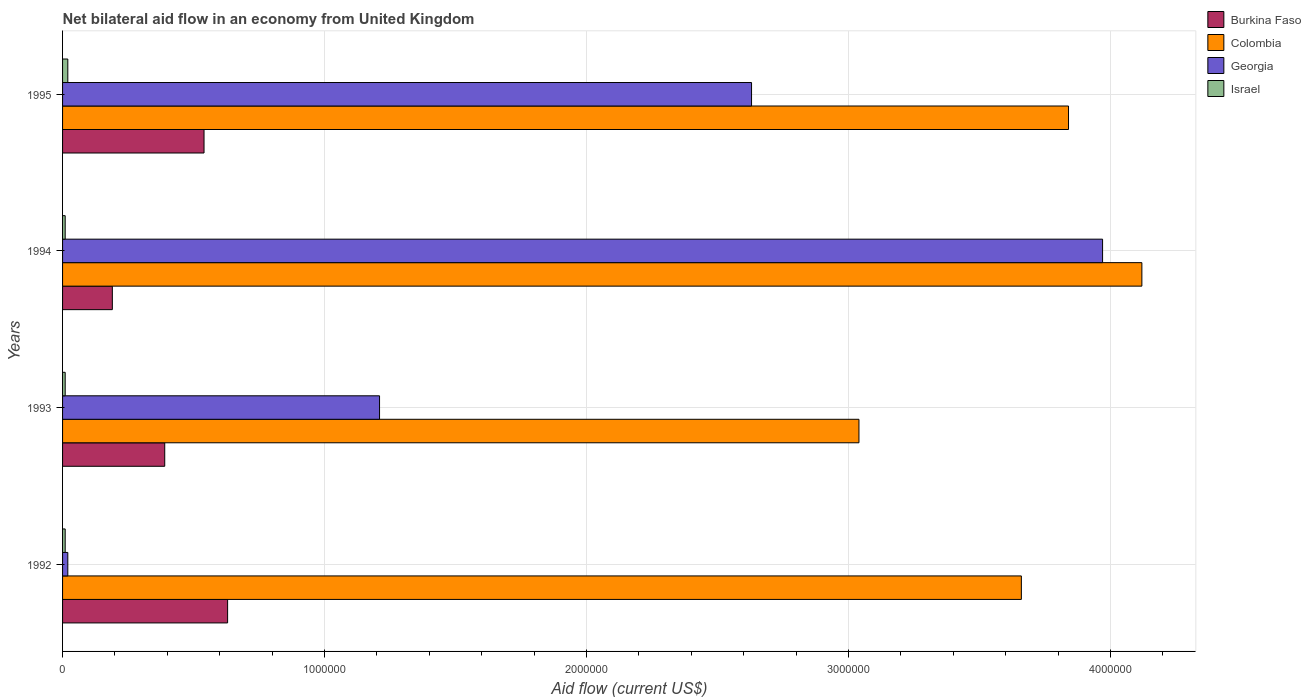How many different coloured bars are there?
Keep it short and to the point. 4. How many bars are there on the 4th tick from the bottom?
Your answer should be very brief. 4. What is the net bilateral aid flow in Colombia in 1993?
Your answer should be compact. 3.04e+06. Across all years, what is the maximum net bilateral aid flow in Georgia?
Give a very brief answer. 3.97e+06. What is the total net bilateral aid flow in Georgia in the graph?
Offer a very short reply. 7.83e+06. What is the difference between the net bilateral aid flow in Colombia in 1993 and that in 1995?
Offer a terse response. -8.00e+05. What is the difference between the net bilateral aid flow in Israel in 1993 and the net bilateral aid flow in Colombia in 1995?
Your answer should be very brief. -3.83e+06. What is the average net bilateral aid flow in Colombia per year?
Offer a terse response. 3.66e+06. In the year 1994, what is the difference between the net bilateral aid flow in Georgia and net bilateral aid flow in Israel?
Your response must be concise. 3.96e+06. What is the ratio of the net bilateral aid flow in Georgia in 1992 to that in 1994?
Provide a short and direct response. 0.01. What is the difference between the highest and the second highest net bilateral aid flow in Colombia?
Give a very brief answer. 2.80e+05. What is the difference between the highest and the lowest net bilateral aid flow in Burkina Faso?
Your answer should be compact. 4.40e+05. Is the sum of the net bilateral aid flow in Israel in 1993 and 1994 greater than the maximum net bilateral aid flow in Georgia across all years?
Your answer should be compact. No. Is it the case that in every year, the sum of the net bilateral aid flow in Georgia and net bilateral aid flow in Burkina Faso is greater than the sum of net bilateral aid flow in Colombia and net bilateral aid flow in Israel?
Your answer should be compact. Yes. What does the 1st bar from the bottom in 1994 represents?
Give a very brief answer. Burkina Faso. Is it the case that in every year, the sum of the net bilateral aid flow in Colombia and net bilateral aid flow in Georgia is greater than the net bilateral aid flow in Israel?
Provide a succinct answer. Yes. How many bars are there?
Your response must be concise. 16. Are all the bars in the graph horizontal?
Ensure brevity in your answer.  Yes. What is the difference between two consecutive major ticks on the X-axis?
Provide a short and direct response. 1.00e+06. Are the values on the major ticks of X-axis written in scientific E-notation?
Your answer should be very brief. No. Does the graph contain any zero values?
Ensure brevity in your answer.  No. Does the graph contain grids?
Keep it short and to the point. Yes. What is the title of the graph?
Keep it short and to the point. Net bilateral aid flow in an economy from United Kingdom. What is the label or title of the X-axis?
Give a very brief answer. Aid flow (current US$). What is the Aid flow (current US$) of Burkina Faso in 1992?
Provide a short and direct response. 6.30e+05. What is the Aid flow (current US$) of Colombia in 1992?
Your response must be concise. 3.66e+06. What is the Aid flow (current US$) of Israel in 1992?
Give a very brief answer. 10000. What is the Aid flow (current US$) of Colombia in 1993?
Offer a terse response. 3.04e+06. What is the Aid flow (current US$) in Georgia in 1993?
Provide a succinct answer. 1.21e+06. What is the Aid flow (current US$) in Burkina Faso in 1994?
Provide a short and direct response. 1.90e+05. What is the Aid flow (current US$) in Colombia in 1994?
Provide a succinct answer. 4.12e+06. What is the Aid flow (current US$) of Georgia in 1994?
Provide a short and direct response. 3.97e+06. What is the Aid flow (current US$) in Israel in 1994?
Provide a short and direct response. 10000. What is the Aid flow (current US$) in Burkina Faso in 1995?
Make the answer very short. 5.40e+05. What is the Aid flow (current US$) of Colombia in 1995?
Provide a short and direct response. 3.84e+06. What is the Aid flow (current US$) in Georgia in 1995?
Make the answer very short. 2.63e+06. Across all years, what is the maximum Aid flow (current US$) of Burkina Faso?
Offer a very short reply. 6.30e+05. Across all years, what is the maximum Aid flow (current US$) of Colombia?
Offer a very short reply. 4.12e+06. Across all years, what is the maximum Aid flow (current US$) of Georgia?
Your answer should be very brief. 3.97e+06. Across all years, what is the maximum Aid flow (current US$) of Israel?
Your answer should be very brief. 2.00e+04. Across all years, what is the minimum Aid flow (current US$) of Colombia?
Provide a succinct answer. 3.04e+06. Across all years, what is the minimum Aid flow (current US$) in Georgia?
Offer a terse response. 2.00e+04. Across all years, what is the minimum Aid flow (current US$) of Israel?
Provide a short and direct response. 10000. What is the total Aid flow (current US$) in Burkina Faso in the graph?
Offer a terse response. 1.75e+06. What is the total Aid flow (current US$) of Colombia in the graph?
Offer a very short reply. 1.47e+07. What is the total Aid flow (current US$) of Georgia in the graph?
Make the answer very short. 7.83e+06. What is the difference between the Aid flow (current US$) in Colombia in 1992 and that in 1993?
Your answer should be compact. 6.20e+05. What is the difference between the Aid flow (current US$) in Georgia in 1992 and that in 1993?
Offer a terse response. -1.19e+06. What is the difference between the Aid flow (current US$) in Burkina Faso in 1992 and that in 1994?
Offer a terse response. 4.40e+05. What is the difference between the Aid flow (current US$) in Colombia in 1992 and that in 1994?
Offer a terse response. -4.60e+05. What is the difference between the Aid flow (current US$) in Georgia in 1992 and that in 1994?
Make the answer very short. -3.95e+06. What is the difference between the Aid flow (current US$) in Burkina Faso in 1992 and that in 1995?
Offer a terse response. 9.00e+04. What is the difference between the Aid flow (current US$) of Georgia in 1992 and that in 1995?
Ensure brevity in your answer.  -2.61e+06. What is the difference between the Aid flow (current US$) in Israel in 1992 and that in 1995?
Give a very brief answer. -10000. What is the difference between the Aid flow (current US$) of Burkina Faso in 1993 and that in 1994?
Provide a succinct answer. 2.00e+05. What is the difference between the Aid flow (current US$) of Colombia in 1993 and that in 1994?
Offer a terse response. -1.08e+06. What is the difference between the Aid flow (current US$) of Georgia in 1993 and that in 1994?
Ensure brevity in your answer.  -2.76e+06. What is the difference between the Aid flow (current US$) in Israel in 1993 and that in 1994?
Offer a very short reply. 0. What is the difference between the Aid flow (current US$) of Colombia in 1993 and that in 1995?
Your answer should be compact. -8.00e+05. What is the difference between the Aid flow (current US$) of Georgia in 1993 and that in 1995?
Provide a succinct answer. -1.42e+06. What is the difference between the Aid flow (current US$) of Burkina Faso in 1994 and that in 1995?
Give a very brief answer. -3.50e+05. What is the difference between the Aid flow (current US$) of Georgia in 1994 and that in 1995?
Keep it short and to the point. 1.34e+06. What is the difference between the Aid flow (current US$) in Israel in 1994 and that in 1995?
Your answer should be very brief. -10000. What is the difference between the Aid flow (current US$) in Burkina Faso in 1992 and the Aid flow (current US$) in Colombia in 1993?
Your response must be concise. -2.41e+06. What is the difference between the Aid flow (current US$) in Burkina Faso in 1992 and the Aid flow (current US$) in Georgia in 1993?
Your response must be concise. -5.80e+05. What is the difference between the Aid flow (current US$) of Burkina Faso in 1992 and the Aid flow (current US$) of Israel in 1993?
Offer a terse response. 6.20e+05. What is the difference between the Aid flow (current US$) of Colombia in 1992 and the Aid flow (current US$) of Georgia in 1993?
Provide a succinct answer. 2.45e+06. What is the difference between the Aid flow (current US$) of Colombia in 1992 and the Aid flow (current US$) of Israel in 1993?
Offer a terse response. 3.65e+06. What is the difference between the Aid flow (current US$) in Burkina Faso in 1992 and the Aid flow (current US$) in Colombia in 1994?
Your answer should be compact. -3.49e+06. What is the difference between the Aid flow (current US$) in Burkina Faso in 1992 and the Aid flow (current US$) in Georgia in 1994?
Ensure brevity in your answer.  -3.34e+06. What is the difference between the Aid flow (current US$) in Burkina Faso in 1992 and the Aid flow (current US$) in Israel in 1994?
Ensure brevity in your answer.  6.20e+05. What is the difference between the Aid flow (current US$) in Colombia in 1992 and the Aid flow (current US$) in Georgia in 1994?
Make the answer very short. -3.10e+05. What is the difference between the Aid flow (current US$) of Colombia in 1992 and the Aid flow (current US$) of Israel in 1994?
Provide a succinct answer. 3.65e+06. What is the difference between the Aid flow (current US$) of Georgia in 1992 and the Aid flow (current US$) of Israel in 1994?
Your answer should be compact. 10000. What is the difference between the Aid flow (current US$) in Burkina Faso in 1992 and the Aid flow (current US$) in Colombia in 1995?
Your answer should be compact. -3.21e+06. What is the difference between the Aid flow (current US$) of Burkina Faso in 1992 and the Aid flow (current US$) of Georgia in 1995?
Ensure brevity in your answer.  -2.00e+06. What is the difference between the Aid flow (current US$) of Burkina Faso in 1992 and the Aid flow (current US$) of Israel in 1995?
Give a very brief answer. 6.10e+05. What is the difference between the Aid flow (current US$) in Colombia in 1992 and the Aid flow (current US$) in Georgia in 1995?
Your answer should be very brief. 1.03e+06. What is the difference between the Aid flow (current US$) of Colombia in 1992 and the Aid flow (current US$) of Israel in 1995?
Offer a very short reply. 3.64e+06. What is the difference between the Aid flow (current US$) in Georgia in 1992 and the Aid flow (current US$) in Israel in 1995?
Give a very brief answer. 0. What is the difference between the Aid flow (current US$) of Burkina Faso in 1993 and the Aid flow (current US$) of Colombia in 1994?
Provide a succinct answer. -3.73e+06. What is the difference between the Aid flow (current US$) of Burkina Faso in 1993 and the Aid flow (current US$) of Georgia in 1994?
Offer a terse response. -3.58e+06. What is the difference between the Aid flow (current US$) of Burkina Faso in 1993 and the Aid flow (current US$) of Israel in 1994?
Your answer should be very brief. 3.80e+05. What is the difference between the Aid flow (current US$) in Colombia in 1993 and the Aid flow (current US$) in Georgia in 1994?
Ensure brevity in your answer.  -9.30e+05. What is the difference between the Aid flow (current US$) of Colombia in 1993 and the Aid flow (current US$) of Israel in 1994?
Offer a terse response. 3.03e+06. What is the difference between the Aid flow (current US$) of Georgia in 1993 and the Aid flow (current US$) of Israel in 1994?
Your answer should be compact. 1.20e+06. What is the difference between the Aid flow (current US$) of Burkina Faso in 1993 and the Aid flow (current US$) of Colombia in 1995?
Give a very brief answer. -3.45e+06. What is the difference between the Aid flow (current US$) in Burkina Faso in 1993 and the Aid flow (current US$) in Georgia in 1995?
Provide a succinct answer. -2.24e+06. What is the difference between the Aid flow (current US$) in Colombia in 1993 and the Aid flow (current US$) in Israel in 1995?
Your response must be concise. 3.02e+06. What is the difference between the Aid flow (current US$) of Georgia in 1993 and the Aid flow (current US$) of Israel in 1995?
Offer a terse response. 1.19e+06. What is the difference between the Aid flow (current US$) in Burkina Faso in 1994 and the Aid flow (current US$) in Colombia in 1995?
Offer a very short reply. -3.65e+06. What is the difference between the Aid flow (current US$) in Burkina Faso in 1994 and the Aid flow (current US$) in Georgia in 1995?
Provide a short and direct response. -2.44e+06. What is the difference between the Aid flow (current US$) of Colombia in 1994 and the Aid flow (current US$) of Georgia in 1995?
Make the answer very short. 1.49e+06. What is the difference between the Aid flow (current US$) of Colombia in 1994 and the Aid flow (current US$) of Israel in 1995?
Your answer should be very brief. 4.10e+06. What is the difference between the Aid flow (current US$) of Georgia in 1994 and the Aid flow (current US$) of Israel in 1995?
Offer a terse response. 3.95e+06. What is the average Aid flow (current US$) of Burkina Faso per year?
Make the answer very short. 4.38e+05. What is the average Aid flow (current US$) of Colombia per year?
Your answer should be compact. 3.66e+06. What is the average Aid flow (current US$) in Georgia per year?
Offer a terse response. 1.96e+06. What is the average Aid flow (current US$) in Israel per year?
Your response must be concise. 1.25e+04. In the year 1992, what is the difference between the Aid flow (current US$) in Burkina Faso and Aid flow (current US$) in Colombia?
Provide a succinct answer. -3.03e+06. In the year 1992, what is the difference between the Aid flow (current US$) in Burkina Faso and Aid flow (current US$) in Israel?
Your answer should be very brief. 6.20e+05. In the year 1992, what is the difference between the Aid flow (current US$) in Colombia and Aid flow (current US$) in Georgia?
Offer a terse response. 3.64e+06. In the year 1992, what is the difference between the Aid flow (current US$) of Colombia and Aid flow (current US$) of Israel?
Give a very brief answer. 3.65e+06. In the year 1993, what is the difference between the Aid flow (current US$) in Burkina Faso and Aid flow (current US$) in Colombia?
Provide a short and direct response. -2.65e+06. In the year 1993, what is the difference between the Aid flow (current US$) in Burkina Faso and Aid flow (current US$) in Georgia?
Your answer should be very brief. -8.20e+05. In the year 1993, what is the difference between the Aid flow (current US$) of Burkina Faso and Aid flow (current US$) of Israel?
Keep it short and to the point. 3.80e+05. In the year 1993, what is the difference between the Aid flow (current US$) in Colombia and Aid flow (current US$) in Georgia?
Give a very brief answer. 1.83e+06. In the year 1993, what is the difference between the Aid flow (current US$) of Colombia and Aid flow (current US$) of Israel?
Your answer should be compact. 3.03e+06. In the year 1993, what is the difference between the Aid flow (current US$) in Georgia and Aid flow (current US$) in Israel?
Offer a terse response. 1.20e+06. In the year 1994, what is the difference between the Aid flow (current US$) in Burkina Faso and Aid flow (current US$) in Colombia?
Provide a succinct answer. -3.93e+06. In the year 1994, what is the difference between the Aid flow (current US$) of Burkina Faso and Aid flow (current US$) of Georgia?
Your answer should be very brief. -3.78e+06. In the year 1994, what is the difference between the Aid flow (current US$) of Burkina Faso and Aid flow (current US$) of Israel?
Provide a succinct answer. 1.80e+05. In the year 1994, what is the difference between the Aid flow (current US$) of Colombia and Aid flow (current US$) of Georgia?
Your response must be concise. 1.50e+05. In the year 1994, what is the difference between the Aid flow (current US$) in Colombia and Aid flow (current US$) in Israel?
Ensure brevity in your answer.  4.11e+06. In the year 1994, what is the difference between the Aid flow (current US$) of Georgia and Aid flow (current US$) of Israel?
Provide a succinct answer. 3.96e+06. In the year 1995, what is the difference between the Aid flow (current US$) in Burkina Faso and Aid flow (current US$) in Colombia?
Your answer should be very brief. -3.30e+06. In the year 1995, what is the difference between the Aid flow (current US$) of Burkina Faso and Aid flow (current US$) of Georgia?
Keep it short and to the point. -2.09e+06. In the year 1995, what is the difference between the Aid flow (current US$) in Burkina Faso and Aid flow (current US$) in Israel?
Ensure brevity in your answer.  5.20e+05. In the year 1995, what is the difference between the Aid flow (current US$) of Colombia and Aid flow (current US$) of Georgia?
Offer a very short reply. 1.21e+06. In the year 1995, what is the difference between the Aid flow (current US$) of Colombia and Aid flow (current US$) of Israel?
Give a very brief answer. 3.82e+06. In the year 1995, what is the difference between the Aid flow (current US$) of Georgia and Aid flow (current US$) of Israel?
Your answer should be compact. 2.61e+06. What is the ratio of the Aid flow (current US$) in Burkina Faso in 1992 to that in 1993?
Your answer should be compact. 1.62. What is the ratio of the Aid flow (current US$) in Colombia in 1992 to that in 1993?
Provide a short and direct response. 1.2. What is the ratio of the Aid flow (current US$) of Georgia in 1992 to that in 1993?
Ensure brevity in your answer.  0.02. What is the ratio of the Aid flow (current US$) in Israel in 1992 to that in 1993?
Your response must be concise. 1. What is the ratio of the Aid flow (current US$) of Burkina Faso in 1992 to that in 1994?
Give a very brief answer. 3.32. What is the ratio of the Aid flow (current US$) in Colombia in 1992 to that in 1994?
Keep it short and to the point. 0.89. What is the ratio of the Aid flow (current US$) in Georgia in 1992 to that in 1994?
Your answer should be compact. 0.01. What is the ratio of the Aid flow (current US$) in Burkina Faso in 1992 to that in 1995?
Your response must be concise. 1.17. What is the ratio of the Aid flow (current US$) of Colombia in 1992 to that in 1995?
Your response must be concise. 0.95. What is the ratio of the Aid flow (current US$) in Georgia in 1992 to that in 1995?
Keep it short and to the point. 0.01. What is the ratio of the Aid flow (current US$) in Israel in 1992 to that in 1995?
Make the answer very short. 0.5. What is the ratio of the Aid flow (current US$) in Burkina Faso in 1993 to that in 1994?
Your answer should be very brief. 2.05. What is the ratio of the Aid flow (current US$) in Colombia in 1993 to that in 1994?
Your answer should be compact. 0.74. What is the ratio of the Aid flow (current US$) of Georgia in 1993 to that in 1994?
Provide a succinct answer. 0.3. What is the ratio of the Aid flow (current US$) of Burkina Faso in 1993 to that in 1995?
Ensure brevity in your answer.  0.72. What is the ratio of the Aid flow (current US$) of Colombia in 1993 to that in 1995?
Your answer should be very brief. 0.79. What is the ratio of the Aid flow (current US$) of Georgia in 1993 to that in 1995?
Make the answer very short. 0.46. What is the ratio of the Aid flow (current US$) in Israel in 1993 to that in 1995?
Keep it short and to the point. 0.5. What is the ratio of the Aid flow (current US$) of Burkina Faso in 1994 to that in 1995?
Keep it short and to the point. 0.35. What is the ratio of the Aid flow (current US$) in Colombia in 1994 to that in 1995?
Your response must be concise. 1.07. What is the ratio of the Aid flow (current US$) of Georgia in 1994 to that in 1995?
Offer a very short reply. 1.51. What is the ratio of the Aid flow (current US$) of Israel in 1994 to that in 1995?
Your answer should be compact. 0.5. What is the difference between the highest and the second highest Aid flow (current US$) in Georgia?
Provide a succinct answer. 1.34e+06. What is the difference between the highest and the second highest Aid flow (current US$) in Israel?
Offer a terse response. 10000. What is the difference between the highest and the lowest Aid flow (current US$) in Colombia?
Provide a succinct answer. 1.08e+06. What is the difference between the highest and the lowest Aid flow (current US$) of Georgia?
Offer a very short reply. 3.95e+06. What is the difference between the highest and the lowest Aid flow (current US$) in Israel?
Make the answer very short. 10000. 